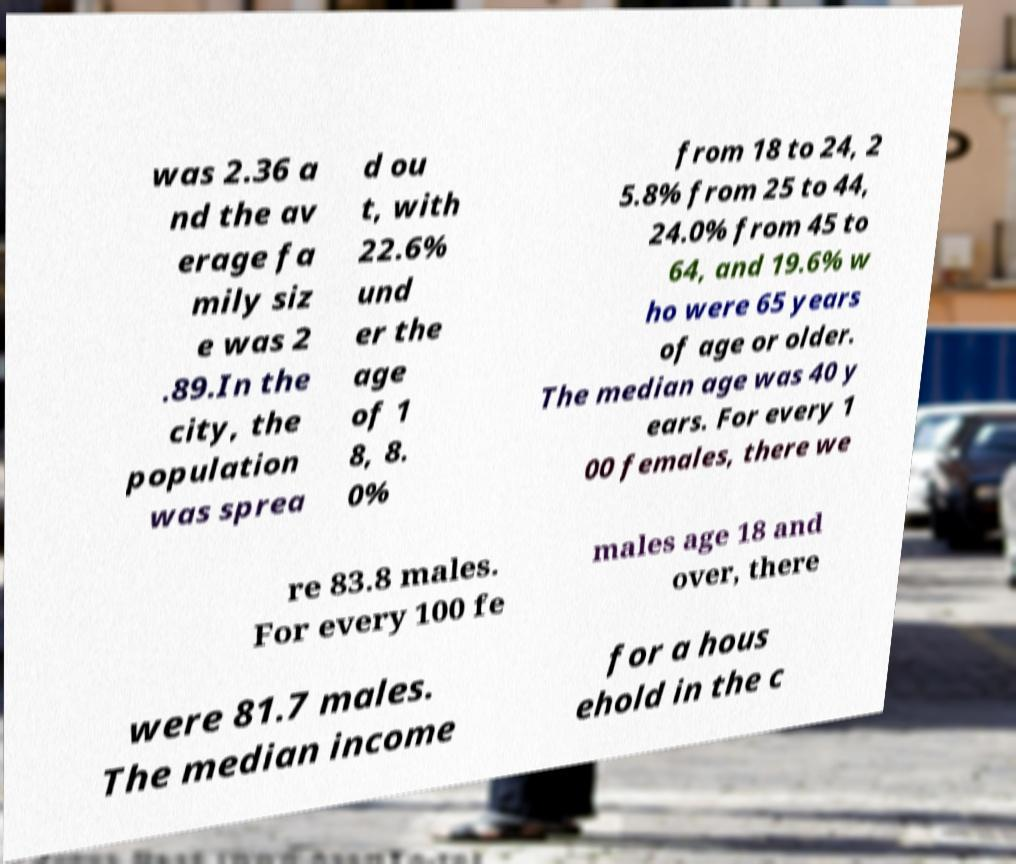There's text embedded in this image that I need extracted. Can you transcribe it verbatim? was 2.36 a nd the av erage fa mily siz e was 2 .89.In the city, the population was sprea d ou t, with 22.6% und er the age of 1 8, 8. 0% from 18 to 24, 2 5.8% from 25 to 44, 24.0% from 45 to 64, and 19.6% w ho were 65 years of age or older. The median age was 40 y ears. For every 1 00 females, there we re 83.8 males. For every 100 fe males age 18 and over, there were 81.7 males. The median income for a hous ehold in the c 